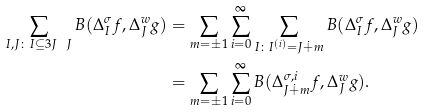Convert formula to latex. <formula><loc_0><loc_0><loc_500><loc_500>\sum _ { I , J \colon I \subseteq 3 J \ J } B ( \Delta _ { I } ^ { \sigma } f , \Delta _ { J } ^ { w } g ) & = \sum _ { m = \pm 1 } \sum _ { i = 0 } ^ { \infty } \sum _ { I \colon I ^ { ( i ) } = J \dot { + } m } B ( \Delta _ { I } ^ { \sigma } f , \Delta _ { J } ^ { w } g ) \\ & = \sum _ { m = \pm 1 } \sum _ { i = 0 } ^ { \infty } B ( \Delta _ { J \dot { + } m } ^ { \sigma , i } f , \Delta _ { J } ^ { w } g ) .</formula> 